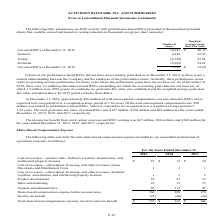According to Activision Blizzard's financial document, What was the total grant date fair value of vested RSUs in 2019? According to the financial document, $147 million (in millions). The relevant text states: "The total grant date fair value of vested RSUs was $147 million, $120 million and $64 million for the years ended December 31, 2019, 2018, and 2017, respectively...." Also, What was the total grant date fair value of vested RSUs in 2018? According to the financial document, $120 million (in millions). The relevant text states: "t date fair value of vested RSUs was $147 million, $120 million and $64 million for the years ended December 31, 2019, 2018, and 2017, respectively...." Also, What was the income tax benefit from stock option exercises and RSU vestings in 2017? According to the financial document, $160 million (in millions). The relevant text states: "and RSU vestings was $47 million, $94 million, and $160 million for..." Also, can you calculate: What is the change in the number of unvested RSUs between 2018 and 2019? Based on the calculation: 9,328-10,623, the result is -1295 (in thousands). This is based on the information: "Unvested RSUs at December 31, 2018 10,623 $ 40.39 Unvested RSUs at December 31, 2019 9,328 $ 32.60..." The key data points involved are: 10,623, 9,328. Also, can you calculate: What is the difference in the weighted-average grant date fair value between granted and vested RSUs? Based on the calculation: 47.86-45.55, the result is 2.31. This is based on the information: "Vested (2,758) 47.86 Granted 4,426 45.55..." The key data points involved are: 45.55, 47.86. Also, can you calculate: What is the difference in the weighted-average grant date fair value between granted and forfeited RSUs? Based on the calculation: 54.61-45.55, the result is 9.06. This is based on the information: "Forfeited (2,963) 54.61 Granted 4,426 45.55..." The key data points involved are: 45.55, 54.61. 